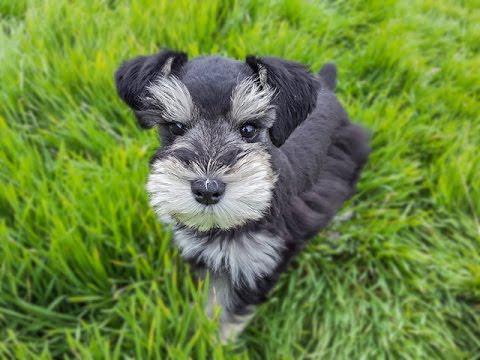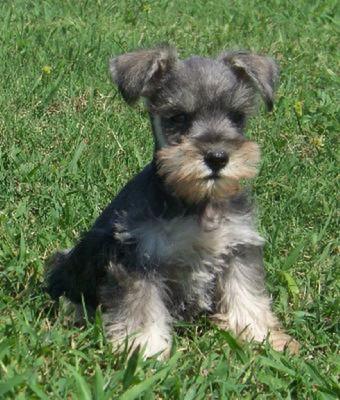The first image is the image on the left, the second image is the image on the right. Evaluate the accuracy of this statement regarding the images: "A dog's collar is visible.". Is it true? Answer yes or no. No. 